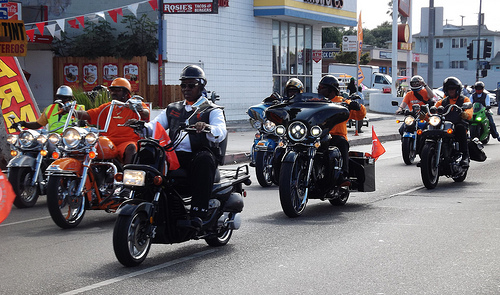<image>
Is there a helmet on the man? Yes. Looking at the image, I can see the helmet is positioned on top of the man, with the man providing support. 